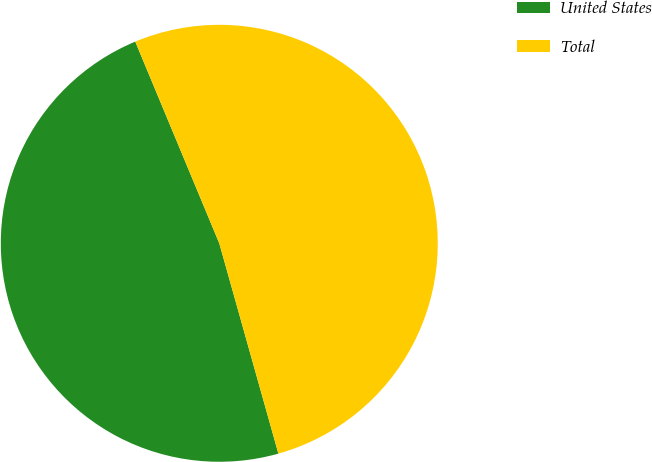Convert chart to OTSL. <chart><loc_0><loc_0><loc_500><loc_500><pie_chart><fcel>United States<fcel>Total<nl><fcel>48.08%<fcel>51.92%<nl></chart> 